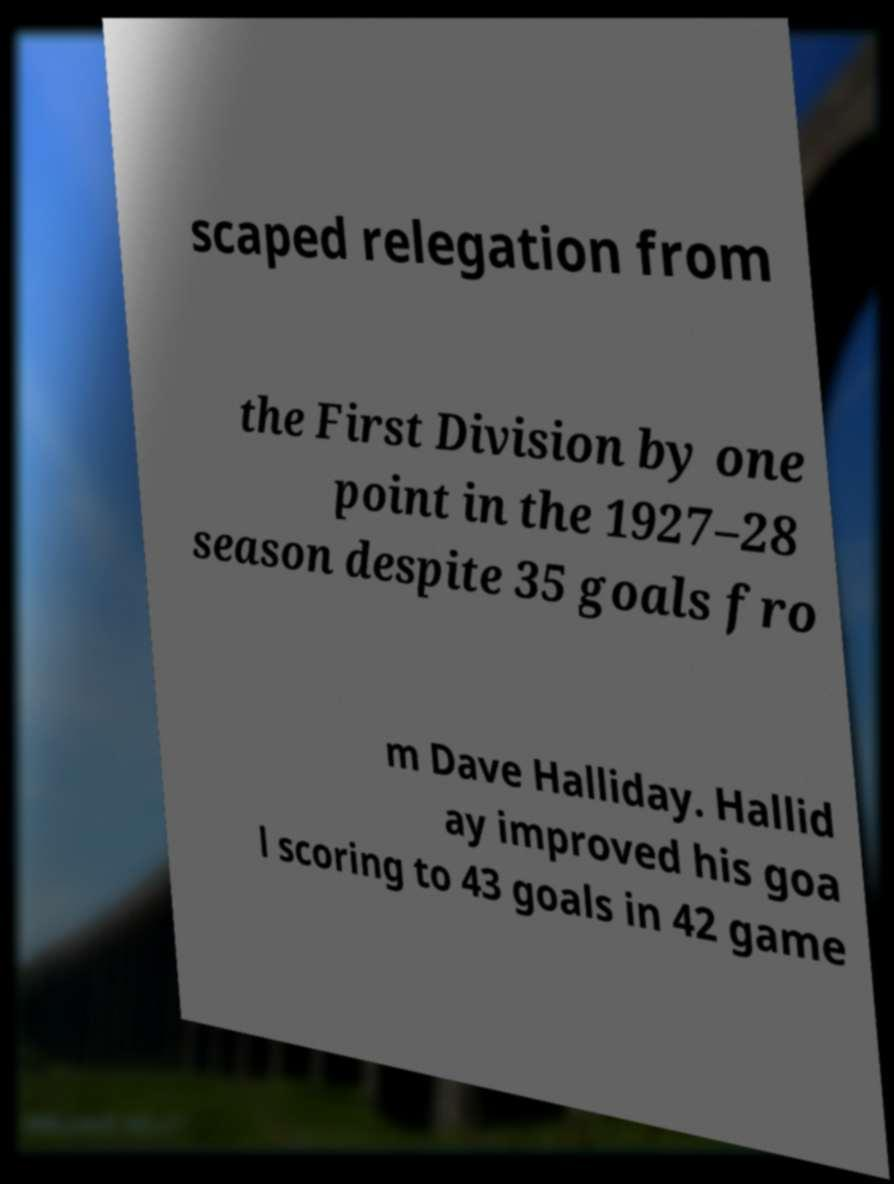Please identify and transcribe the text found in this image. scaped relegation from the First Division by one point in the 1927–28 season despite 35 goals fro m Dave Halliday. Hallid ay improved his goa l scoring to 43 goals in 42 game 